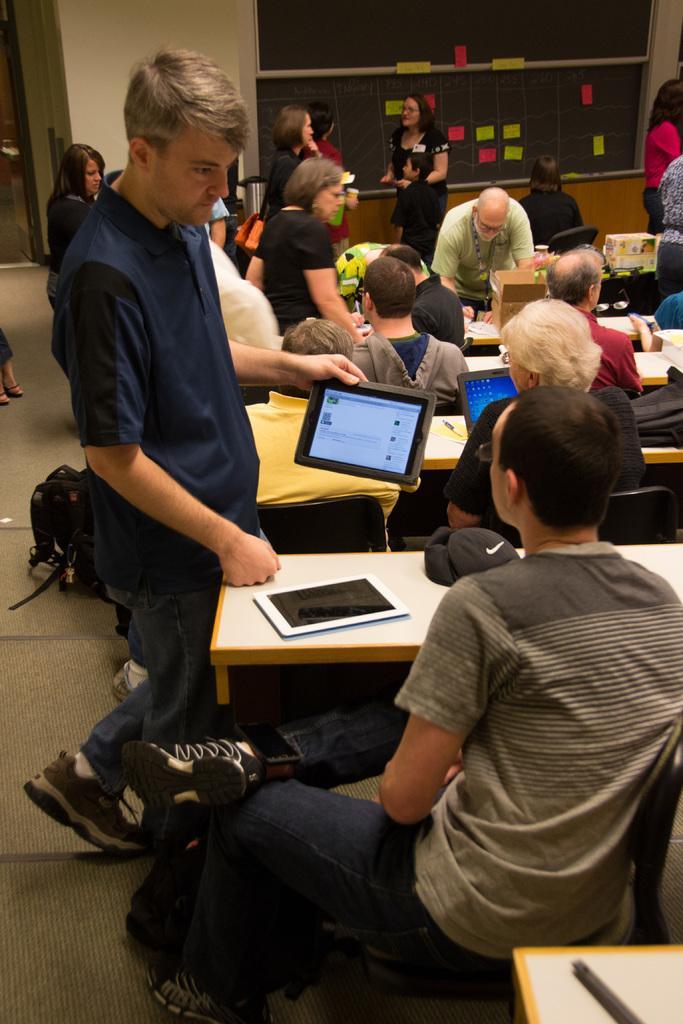How would you summarize this image in a sentence or two? In this image there are people sitting on the chairs. In front of them there are tables. On top of it there are laptops and a few other objects. In the background of the image there are boards. There is a wall. At the bottom of the image there is a mat. 